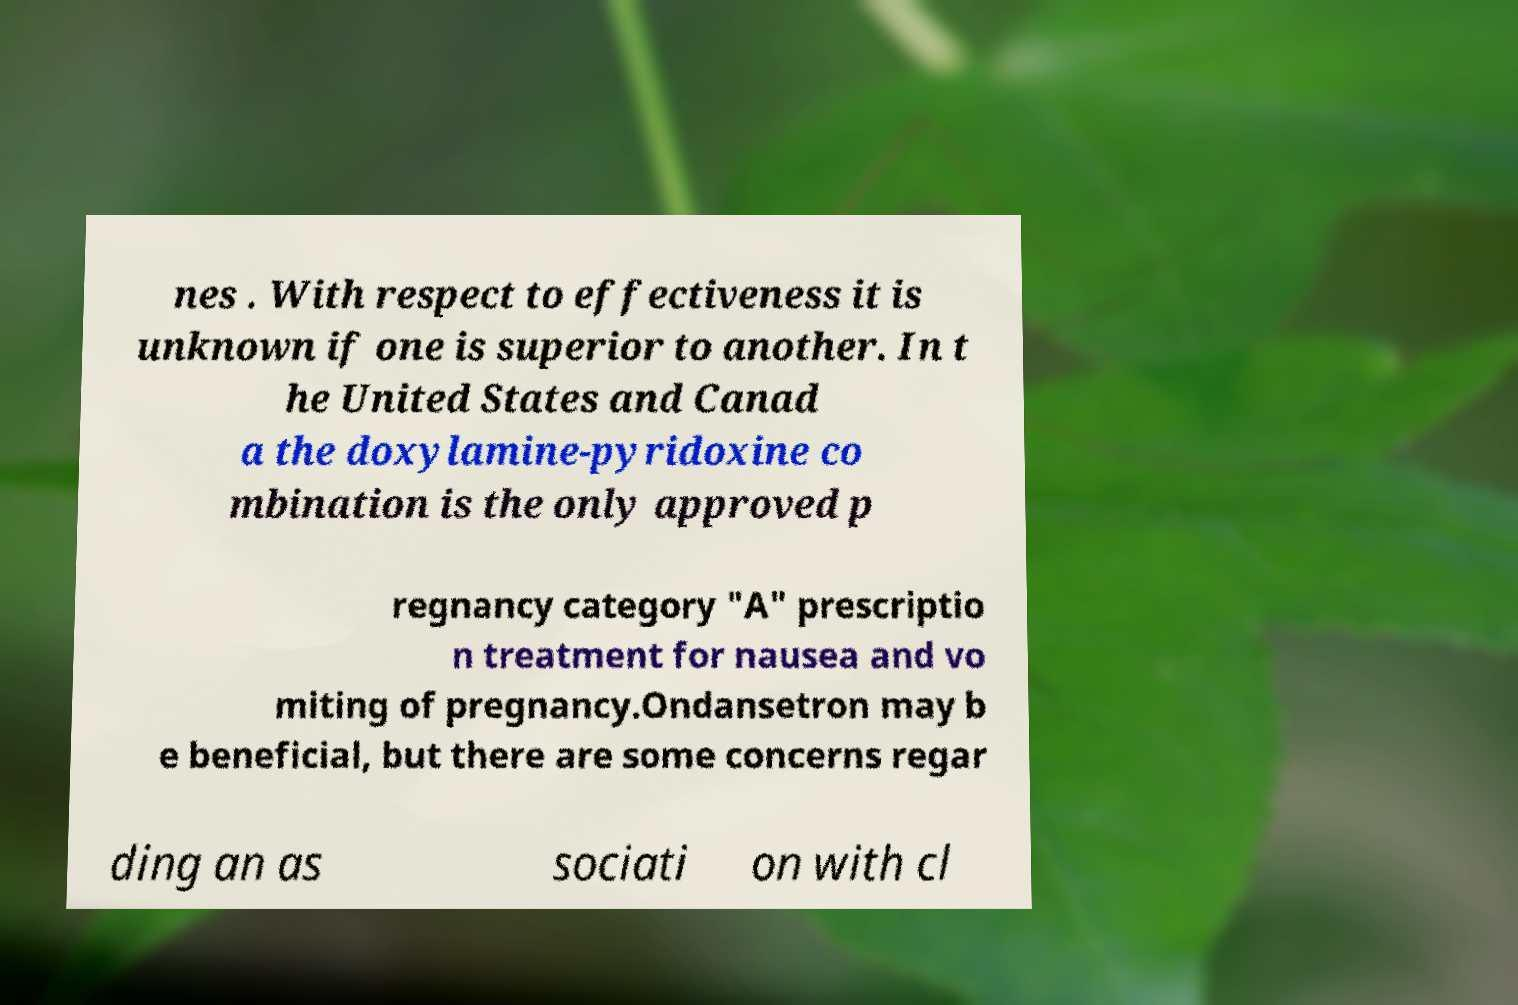Please read and relay the text visible in this image. What does it say? nes . With respect to effectiveness it is unknown if one is superior to another. In t he United States and Canad a the doxylamine-pyridoxine co mbination is the only approved p regnancy category "A" prescriptio n treatment for nausea and vo miting of pregnancy.Ondansetron may b e beneficial, but there are some concerns regar ding an as sociati on with cl 